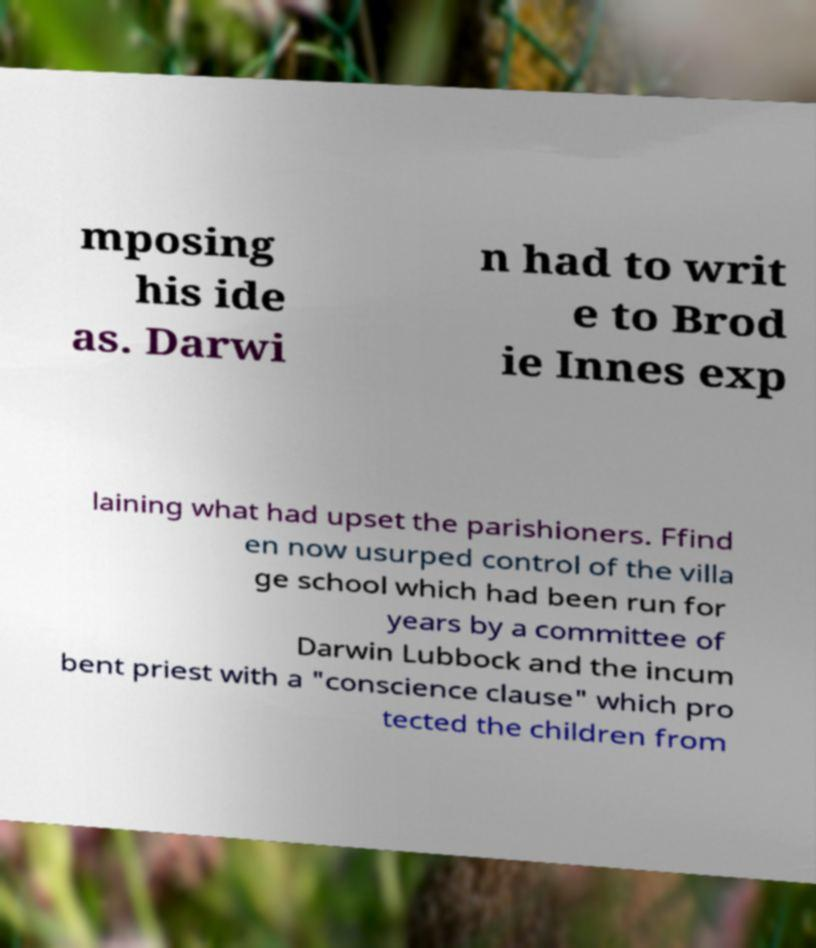Could you extract and type out the text from this image? mposing his ide as. Darwi n had to writ e to Brod ie Innes exp laining what had upset the parishioners. Ffind en now usurped control of the villa ge school which had been run for years by a committee of Darwin Lubbock and the incum bent priest with a "conscience clause" which pro tected the children from 